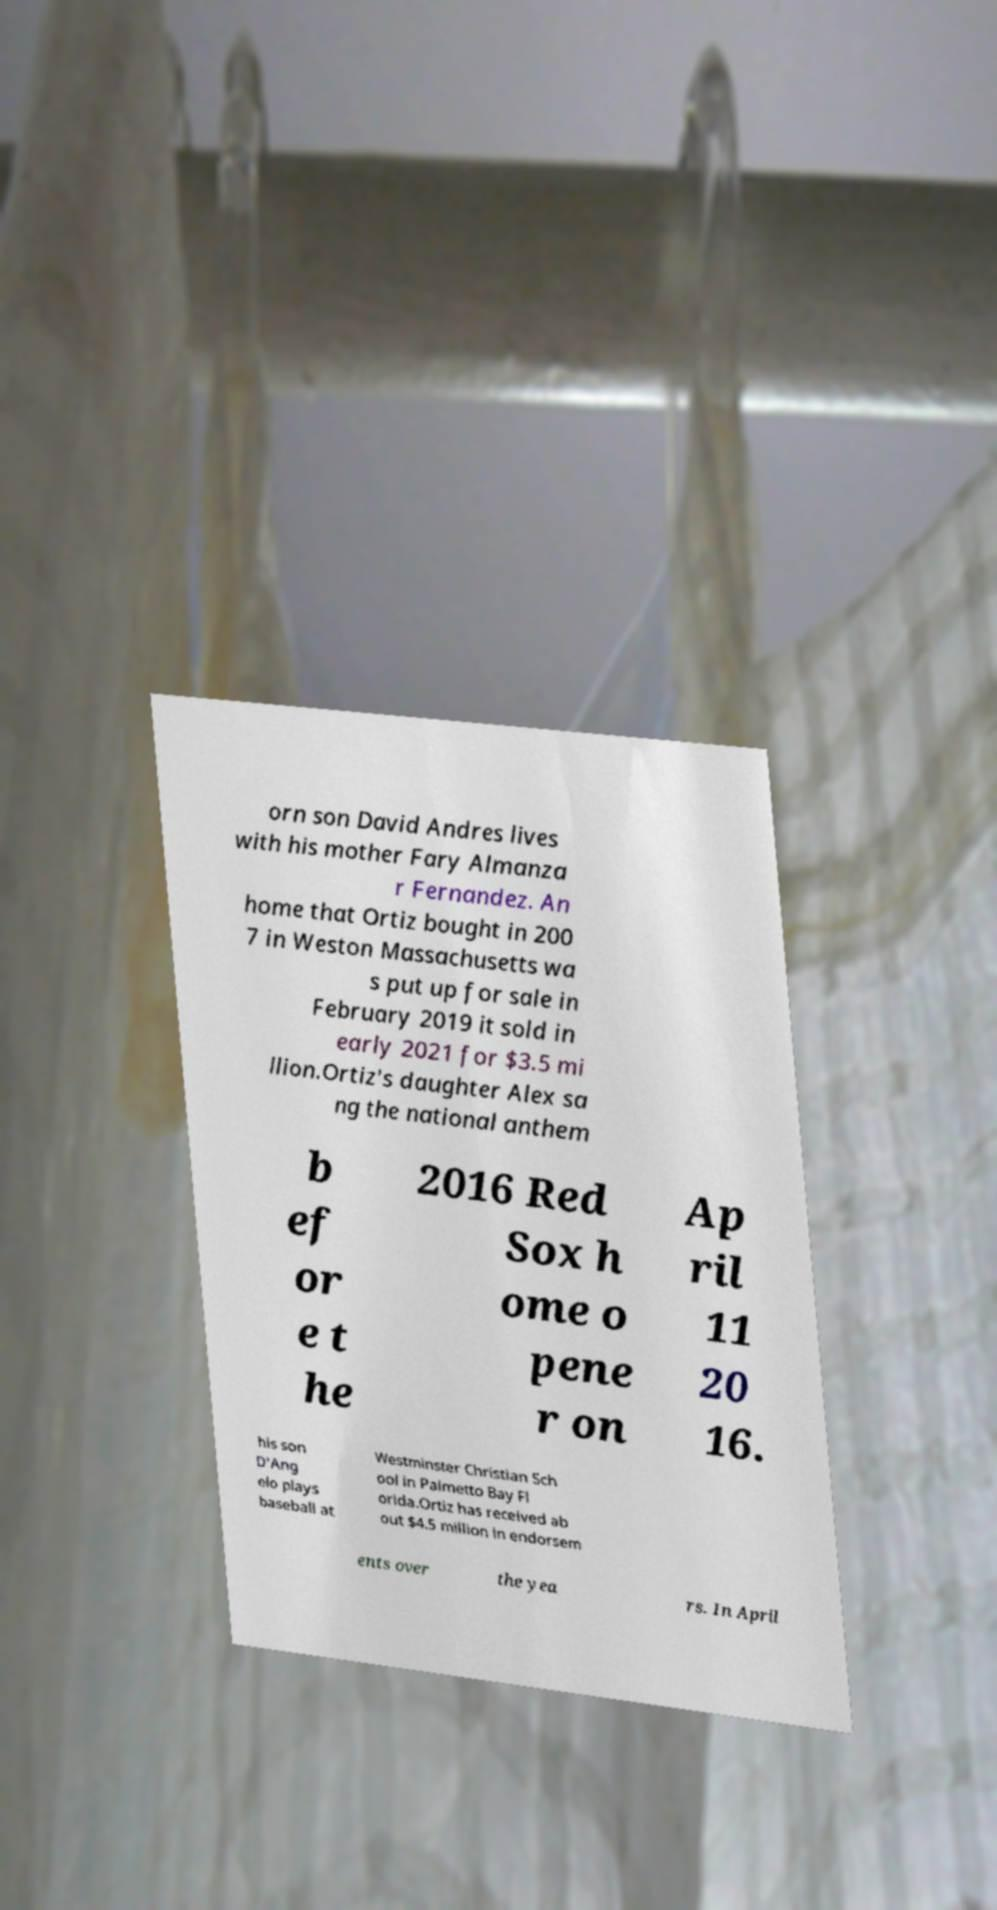Could you assist in decoding the text presented in this image and type it out clearly? orn son David Andres lives with his mother Fary Almanza r Fernandez. An home that Ortiz bought in 200 7 in Weston Massachusetts wa s put up for sale in February 2019 it sold in early 2021 for $3.5 mi llion.Ortiz's daughter Alex sa ng the national anthem b ef or e t he 2016 Red Sox h ome o pene r on Ap ril 11 20 16. his son D'Ang elo plays baseball at Westminster Christian Sch ool in Palmetto Bay Fl orida.Ortiz has received ab out $4.5 million in endorsem ents over the yea rs. In April 